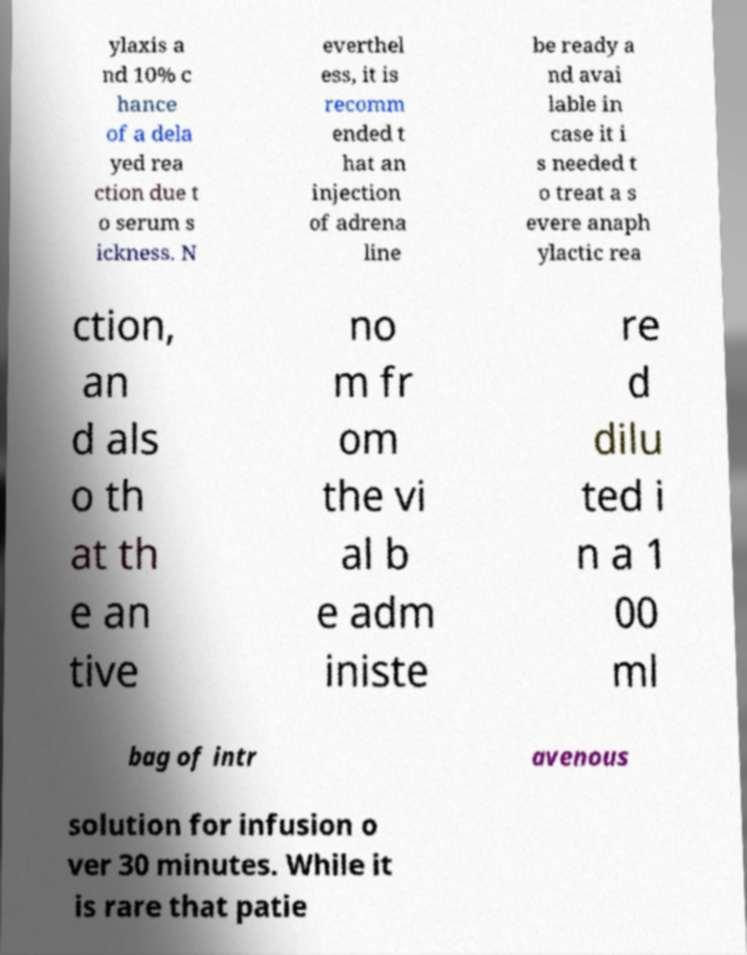What messages or text are displayed in this image? I need them in a readable, typed format. ylaxis a nd 10% c hance of a dela yed rea ction due t o serum s ickness. N everthel ess, it is recomm ended t hat an injection of adrena line be ready a nd avai lable in case it i s needed t o treat a s evere anaph ylactic rea ction, an d als o th at th e an tive no m fr om the vi al b e adm iniste re d dilu ted i n a 1 00 ml bag of intr avenous solution for infusion o ver 30 minutes. While it is rare that patie 